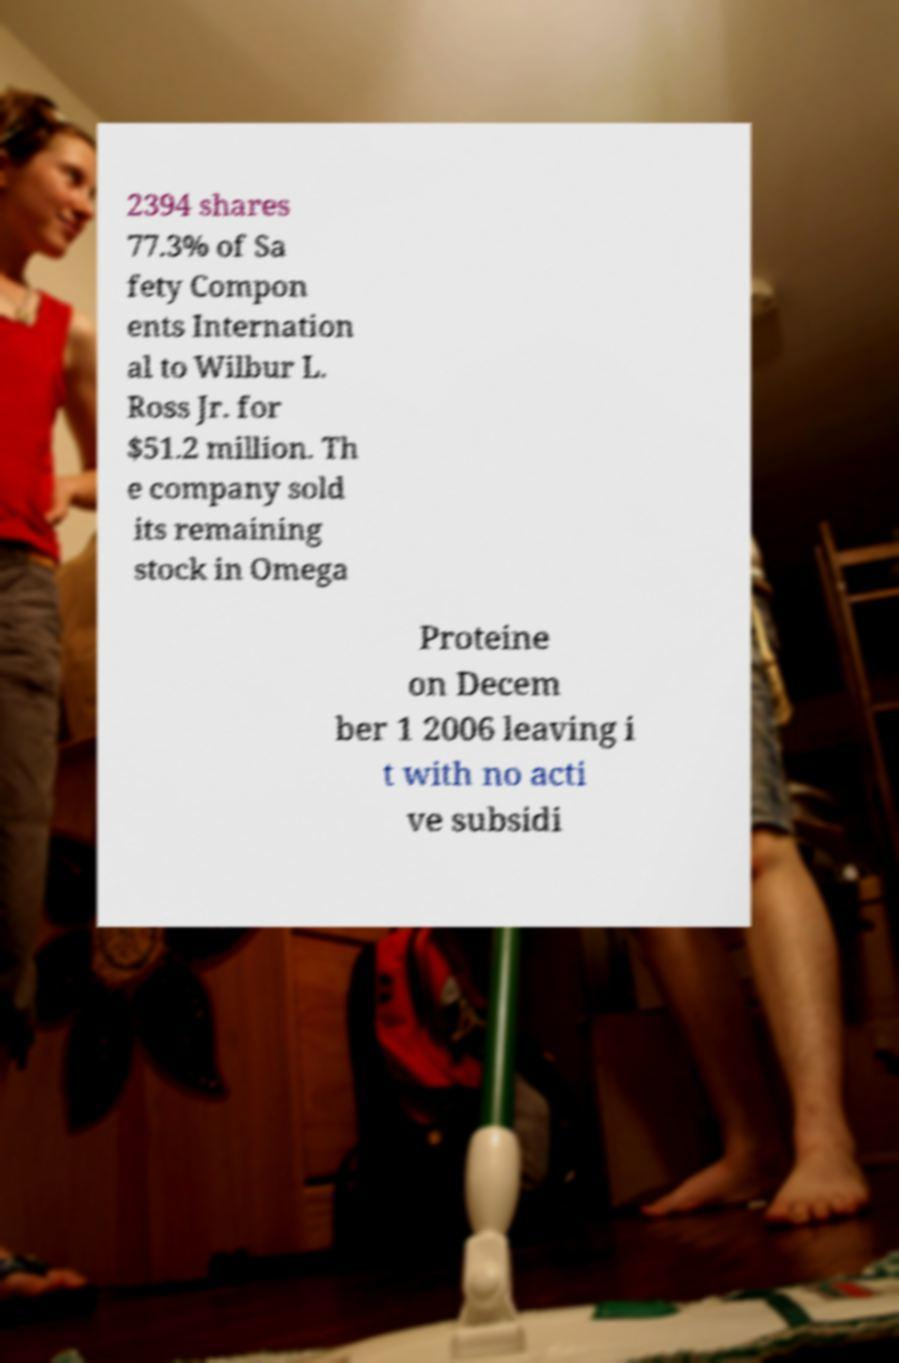Please read and relay the text visible in this image. What does it say? 2394 shares 77.3% of Sa fety Compon ents Internation al to Wilbur L. Ross Jr. for $51.2 million. Th e company sold its remaining stock in Omega Proteine on Decem ber 1 2006 leaving i t with no acti ve subsidi 